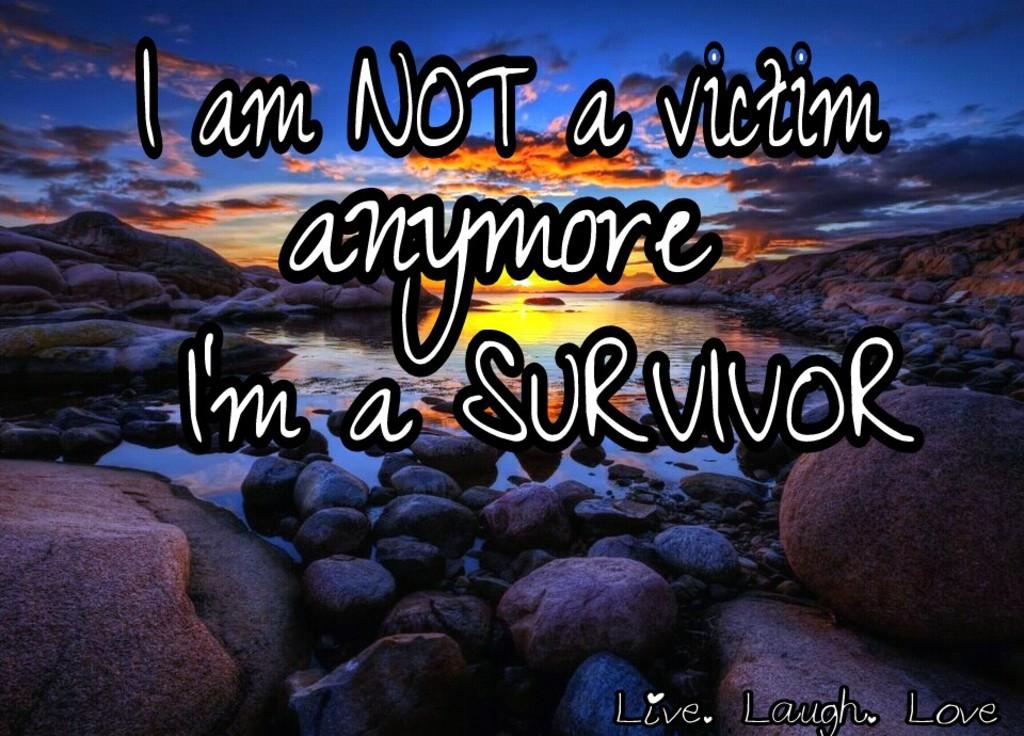What 3 words are at the bottom of this?
Provide a short and direct response. Live laugh love. 